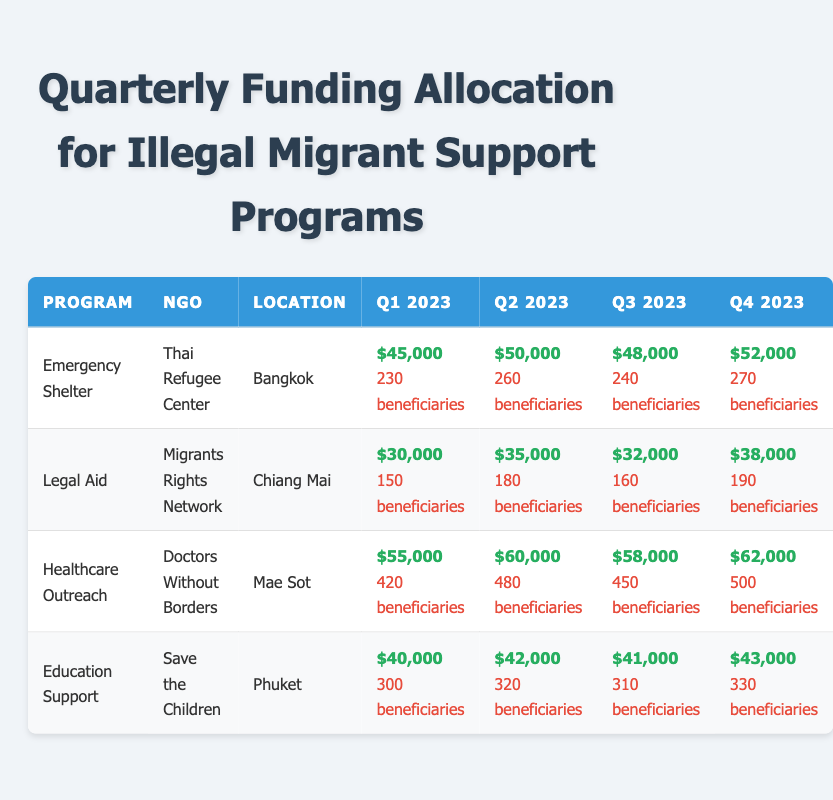What was the total funding for Emergency Shelter programs in Q2 2023? The funding for Emergency Shelter in Q2 2023 is $50,000. This value is directly obtained from the table under the corresponding columns for Emergency Shelter and Q2 2023.
Answer: $50,000 Which NGO provided the highest funding for Healthcare Outreach in Q4 2023? In Q4 2023, the Healthcare Outreach program received $62,000 in funding from Doctors Without Borders. This is the highest among the listed programs for that quarter, obtained by reviewing the Healthcare Outreach row for Q4 2023.
Answer: Doctors Without Borders How much total funding was allocated to Legal Aid across all quarters? The total funding for Legal Aid is calculated by summing up the values for each quarter: $30,000 + $35,000 + $32,000 + $38,000 = $135,000. Hence, the total is derived from the individual amounts across all quarters provided in the table for Legal Aid.
Answer: $135,000 Did the beneficiaries for Education Support program increase or decrease from Q1 to Q4 2023? Beneficiaries for Education Support in Q1 2023 were 300, while in Q4 2023 they were 330, which indicates an increase of 30 beneficiaries. This can be determined by comparing the values directly in the Education Support row across the Q1 and Q4 columns.
Answer: Increase What is the average funding allocated to Emergency Shelter over the four quarters? The average funding is found by summing the funds in each quarter: $45,000 + $50,000 + $48,000 + $52,000 = $195,000. There are four quarters, so the average is $195,000 / 4 = $48,750. This is calculated by isolating the Emergency Shelter funding values and performing the arithmetic operations to find the average.
Answer: $48,750 Was the funding for Healthcare Outreach in Q3 2023 higher or lower than the funding in Q1 2023? The Healthcare Outreach funding for Q3 2023 was $58,000, compared to $55,000 in Q1 2023. Since $58,000 > $55,000, it indicates that the funding in Q3 2023 was higher. This comparison is made by directly referencing the respective rows and columns in the table.
Answer: Higher What is the total number of beneficiaries for Education Support across all quarters? The total number of beneficiaries for Education Support is 300 + 320 + 310 + 330 = 1260. This conclusion is reached by adding up the beneficiaries for the Education Support program as noted in each quarter of the table.
Answer: 1260 Which program served the most beneficiaries in Q2 2023? Healthcare Outreach served the most beneficiaries in Q2 2023 with 480, compared to other programs in the same quarter (Emergency Shelter: 260 and Legal Aid: 180). This is determined by reviewing the beneficiaries' counts for each program in Q2 2023 and comparing them.
Answer: Healthcare Outreach 